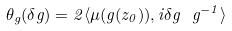<formula> <loc_0><loc_0><loc_500><loc_500>\theta _ { g } ( \delta g ) = 2 \langle \mu ( g ( z _ { 0 } ) ) , i \delta g \ g ^ { - 1 } \rangle</formula> 